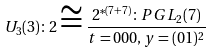Convert formula to latex. <formula><loc_0><loc_0><loc_500><loc_500>U _ { 3 } ( 3 ) \colon 2 \cong \frac { 2 ^ { * ( 7 + 7 ) } \colon P G L _ { 2 } ( 7 ) } { t = { 0 } 0 { 0 } , y = ( { 0 } 1 ) ^ { 2 } }</formula> 